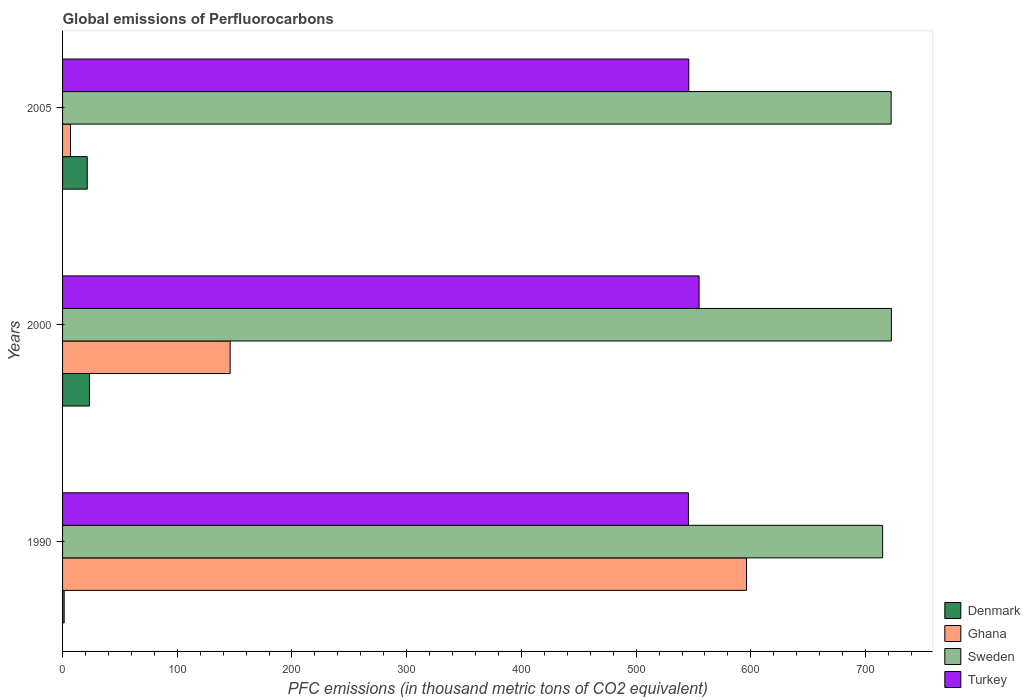Are the number of bars per tick equal to the number of legend labels?
Your answer should be very brief. Yes. How many bars are there on the 1st tick from the top?
Make the answer very short. 4. What is the label of the 2nd group of bars from the top?
Provide a short and direct response. 2000. In how many cases, is the number of bars for a given year not equal to the number of legend labels?
Provide a short and direct response. 0. What is the global emissions of Perfluorocarbons in Denmark in 2005?
Provide a succinct answer. 21.5. Across all years, what is the maximum global emissions of Perfluorocarbons in Turkey?
Give a very brief answer. 554.9. Across all years, what is the minimum global emissions of Perfluorocarbons in Denmark?
Provide a short and direct response. 1.4. In which year was the global emissions of Perfluorocarbons in Turkey maximum?
Ensure brevity in your answer.  2000. What is the total global emissions of Perfluorocarbons in Turkey in the graph?
Provide a short and direct response. 1646.4. What is the difference between the global emissions of Perfluorocarbons in Turkey in 1990 and the global emissions of Perfluorocarbons in Denmark in 2005?
Provide a succinct answer. 524.1. What is the average global emissions of Perfluorocarbons in Sweden per year?
Give a very brief answer. 719.9. In the year 2005, what is the difference between the global emissions of Perfluorocarbons in Ghana and global emissions of Perfluorocarbons in Turkey?
Keep it short and to the point. -539. What is the ratio of the global emissions of Perfluorocarbons in Sweden in 1990 to that in 2000?
Provide a short and direct response. 0.99. What is the difference between the highest and the second highest global emissions of Perfluorocarbons in Denmark?
Make the answer very short. 1.9. What is the difference between the highest and the lowest global emissions of Perfluorocarbons in Turkey?
Offer a very short reply. 9.3. In how many years, is the global emissions of Perfluorocarbons in Sweden greater than the average global emissions of Perfluorocarbons in Sweden taken over all years?
Offer a very short reply. 2. What does the 2nd bar from the top in 1990 represents?
Ensure brevity in your answer.  Sweden. What does the 2nd bar from the bottom in 2005 represents?
Your response must be concise. Ghana. How many bars are there?
Give a very brief answer. 12. Are all the bars in the graph horizontal?
Your response must be concise. Yes. What is the difference between two consecutive major ticks on the X-axis?
Your answer should be very brief. 100. Does the graph contain any zero values?
Your answer should be very brief. No. How many legend labels are there?
Keep it short and to the point. 4. What is the title of the graph?
Offer a terse response. Global emissions of Perfluorocarbons. Does "Andorra" appear as one of the legend labels in the graph?
Your answer should be very brief. No. What is the label or title of the X-axis?
Provide a short and direct response. PFC emissions (in thousand metric tons of CO2 equivalent). What is the PFC emissions (in thousand metric tons of CO2 equivalent) of Ghana in 1990?
Your answer should be very brief. 596.2. What is the PFC emissions (in thousand metric tons of CO2 equivalent) in Sweden in 1990?
Ensure brevity in your answer.  714.9. What is the PFC emissions (in thousand metric tons of CO2 equivalent) of Turkey in 1990?
Ensure brevity in your answer.  545.6. What is the PFC emissions (in thousand metric tons of CO2 equivalent) in Denmark in 2000?
Provide a short and direct response. 23.4. What is the PFC emissions (in thousand metric tons of CO2 equivalent) in Ghana in 2000?
Provide a succinct answer. 146.1. What is the PFC emissions (in thousand metric tons of CO2 equivalent) of Sweden in 2000?
Make the answer very short. 722.5. What is the PFC emissions (in thousand metric tons of CO2 equivalent) in Turkey in 2000?
Your answer should be very brief. 554.9. What is the PFC emissions (in thousand metric tons of CO2 equivalent) of Denmark in 2005?
Provide a short and direct response. 21.5. What is the PFC emissions (in thousand metric tons of CO2 equivalent) in Sweden in 2005?
Keep it short and to the point. 722.3. What is the PFC emissions (in thousand metric tons of CO2 equivalent) of Turkey in 2005?
Provide a short and direct response. 545.9. Across all years, what is the maximum PFC emissions (in thousand metric tons of CO2 equivalent) in Denmark?
Keep it short and to the point. 23.4. Across all years, what is the maximum PFC emissions (in thousand metric tons of CO2 equivalent) of Ghana?
Your answer should be very brief. 596.2. Across all years, what is the maximum PFC emissions (in thousand metric tons of CO2 equivalent) of Sweden?
Ensure brevity in your answer.  722.5. Across all years, what is the maximum PFC emissions (in thousand metric tons of CO2 equivalent) in Turkey?
Provide a short and direct response. 554.9. Across all years, what is the minimum PFC emissions (in thousand metric tons of CO2 equivalent) in Sweden?
Give a very brief answer. 714.9. Across all years, what is the minimum PFC emissions (in thousand metric tons of CO2 equivalent) in Turkey?
Offer a terse response. 545.6. What is the total PFC emissions (in thousand metric tons of CO2 equivalent) of Denmark in the graph?
Make the answer very short. 46.3. What is the total PFC emissions (in thousand metric tons of CO2 equivalent) in Ghana in the graph?
Your response must be concise. 749.2. What is the total PFC emissions (in thousand metric tons of CO2 equivalent) of Sweden in the graph?
Ensure brevity in your answer.  2159.7. What is the total PFC emissions (in thousand metric tons of CO2 equivalent) in Turkey in the graph?
Make the answer very short. 1646.4. What is the difference between the PFC emissions (in thousand metric tons of CO2 equivalent) in Ghana in 1990 and that in 2000?
Provide a succinct answer. 450.1. What is the difference between the PFC emissions (in thousand metric tons of CO2 equivalent) of Sweden in 1990 and that in 2000?
Your response must be concise. -7.6. What is the difference between the PFC emissions (in thousand metric tons of CO2 equivalent) in Turkey in 1990 and that in 2000?
Your answer should be very brief. -9.3. What is the difference between the PFC emissions (in thousand metric tons of CO2 equivalent) of Denmark in 1990 and that in 2005?
Offer a very short reply. -20.1. What is the difference between the PFC emissions (in thousand metric tons of CO2 equivalent) in Ghana in 1990 and that in 2005?
Keep it short and to the point. 589.3. What is the difference between the PFC emissions (in thousand metric tons of CO2 equivalent) of Sweden in 1990 and that in 2005?
Keep it short and to the point. -7.4. What is the difference between the PFC emissions (in thousand metric tons of CO2 equivalent) of Turkey in 1990 and that in 2005?
Provide a succinct answer. -0.3. What is the difference between the PFC emissions (in thousand metric tons of CO2 equivalent) of Denmark in 2000 and that in 2005?
Make the answer very short. 1.9. What is the difference between the PFC emissions (in thousand metric tons of CO2 equivalent) of Ghana in 2000 and that in 2005?
Provide a succinct answer. 139.2. What is the difference between the PFC emissions (in thousand metric tons of CO2 equivalent) of Denmark in 1990 and the PFC emissions (in thousand metric tons of CO2 equivalent) of Ghana in 2000?
Give a very brief answer. -144.7. What is the difference between the PFC emissions (in thousand metric tons of CO2 equivalent) in Denmark in 1990 and the PFC emissions (in thousand metric tons of CO2 equivalent) in Sweden in 2000?
Your answer should be very brief. -721.1. What is the difference between the PFC emissions (in thousand metric tons of CO2 equivalent) of Denmark in 1990 and the PFC emissions (in thousand metric tons of CO2 equivalent) of Turkey in 2000?
Offer a terse response. -553.5. What is the difference between the PFC emissions (in thousand metric tons of CO2 equivalent) of Ghana in 1990 and the PFC emissions (in thousand metric tons of CO2 equivalent) of Sweden in 2000?
Your answer should be very brief. -126.3. What is the difference between the PFC emissions (in thousand metric tons of CO2 equivalent) of Ghana in 1990 and the PFC emissions (in thousand metric tons of CO2 equivalent) of Turkey in 2000?
Provide a short and direct response. 41.3. What is the difference between the PFC emissions (in thousand metric tons of CO2 equivalent) of Sweden in 1990 and the PFC emissions (in thousand metric tons of CO2 equivalent) of Turkey in 2000?
Provide a short and direct response. 160. What is the difference between the PFC emissions (in thousand metric tons of CO2 equivalent) of Denmark in 1990 and the PFC emissions (in thousand metric tons of CO2 equivalent) of Sweden in 2005?
Your answer should be very brief. -720.9. What is the difference between the PFC emissions (in thousand metric tons of CO2 equivalent) of Denmark in 1990 and the PFC emissions (in thousand metric tons of CO2 equivalent) of Turkey in 2005?
Ensure brevity in your answer.  -544.5. What is the difference between the PFC emissions (in thousand metric tons of CO2 equivalent) in Ghana in 1990 and the PFC emissions (in thousand metric tons of CO2 equivalent) in Sweden in 2005?
Provide a succinct answer. -126.1. What is the difference between the PFC emissions (in thousand metric tons of CO2 equivalent) of Ghana in 1990 and the PFC emissions (in thousand metric tons of CO2 equivalent) of Turkey in 2005?
Ensure brevity in your answer.  50.3. What is the difference between the PFC emissions (in thousand metric tons of CO2 equivalent) in Sweden in 1990 and the PFC emissions (in thousand metric tons of CO2 equivalent) in Turkey in 2005?
Give a very brief answer. 169. What is the difference between the PFC emissions (in thousand metric tons of CO2 equivalent) in Denmark in 2000 and the PFC emissions (in thousand metric tons of CO2 equivalent) in Sweden in 2005?
Your response must be concise. -698.9. What is the difference between the PFC emissions (in thousand metric tons of CO2 equivalent) of Denmark in 2000 and the PFC emissions (in thousand metric tons of CO2 equivalent) of Turkey in 2005?
Offer a very short reply. -522.5. What is the difference between the PFC emissions (in thousand metric tons of CO2 equivalent) in Ghana in 2000 and the PFC emissions (in thousand metric tons of CO2 equivalent) in Sweden in 2005?
Provide a short and direct response. -576.2. What is the difference between the PFC emissions (in thousand metric tons of CO2 equivalent) of Ghana in 2000 and the PFC emissions (in thousand metric tons of CO2 equivalent) of Turkey in 2005?
Make the answer very short. -399.8. What is the difference between the PFC emissions (in thousand metric tons of CO2 equivalent) in Sweden in 2000 and the PFC emissions (in thousand metric tons of CO2 equivalent) in Turkey in 2005?
Keep it short and to the point. 176.6. What is the average PFC emissions (in thousand metric tons of CO2 equivalent) of Denmark per year?
Give a very brief answer. 15.43. What is the average PFC emissions (in thousand metric tons of CO2 equivalent) of Ghana per year?
Your answer should be very brief. 249.73. What is the average PFC emissions (in thousand metric tons of CO2 equivalent) of Sweden per year?
Make the answer very short. 719.9. What is the average PFC emissions (in thousand metric tons of CO2 equivalent) in Turkey per year?
Provide a short and direct response. 548.8. In the year 1990, what is the difference between the PFC emissions (in thousand metric tons of CO2 equivalent) in Denmark and PFC emissions (in thousand metric tons of CO2 equivalent) in Ghana?
Ensure brevity in your answer.  -594.8. In the year 1990, what is the difference between the PFC emissions (in thousand metric tons of CO2 equivalent) of Denmark and PFC emissions (in thousand metric tons of CO2 equivalent) of Sweden?
Keep it short and to the point. -713.5. In the year 1990, what is the difference between the PFC emissions (in thousand metric tons of CO2 equivalent) of Denmark and PFC emissions (in thousand metric tons of CO2 equivalent) of Turkey?
Offer a very short reply. -544.2. In the year 1990, what is the difference between the PFC emissions (in thousand metric tons of CO2 equivalent) of Ghana and PFC emissions (in thousand metric tons of CO2 equivalent) of Sweden?
Offer a very short reply. -118.7. In the year 1990, what is the difference between the PFC emissions (in thousand metric tons of CO2 equivalent) in Ghana and PFC emissions (in thousand metric tons of CO2 equivalent) in Turkey?
Your answer should be compact. 50.6. In the year 1990, what is the difference between the PFC emissions (in thousand metric tons of CO2 equivalent) of Sweden and PFC emissions (in thousand metric tons of CO2 equivalent) of Turkey?
Give a very brief answer. 169.3. In the year 2000, what is the difference between the PFC emissions (in thousand metric tons of CO2 equivalent) in Denmark and PFC emissions (in thousand metric tons of CO2 equivalent) in Ghana?
Your answer should be very brief. -122.7. In the year 2000, what is the difference between the PFC emissions (in thousand metric tons of CO2 equivalent) of Denmark and PFC emissions (in thousand metric tons of CO2 equivalent) of Sweden?
Provide a short and direct response. -699.1. In the year 2000, what is the difference between the PFC emissions (in thousand metric tons of CO2 equivalent) in Denmark and PFC emissions (in thousand metric tons of CO2 equivalent) in Turkey?
Your answer should be very brief. -531.5. In the year 2000, what is the difference between the PFC emissions (in thousand metric tons of CO2 equivalent) of Ghana and PFC emissions (in thousand metric tons of CO2 equivalent) of Sweden?
Your response must be concise. -576.4. In the year 2000, what is the difference between the PFC emissions (in thousand metric tons of CO2 equivalent) of Ghana and PFC emissions (in thousand metric tons of CO2 equivalent) of Turkey?
Offer a terse response. -408.8. In the year 2000, what is the difference between the PFC emissions (in thousand metric tons of CO2 equivalent) of Sweden and PFC emissions (in thousand metric tons of CO2 equivalent) of Turkey?
Offer a terse response. 167.6. In the year 2005, what is the difference between the PFC emissions (in thousand metric tons of CO2 equivalent) of Denmark and PFC emissions (in thousand metric tons of CO2 equivalent) of Ghana?
Your answer should be very brief. 14.6. In the year 2005, what is the difference between the PFC emissions (in thousand metric tons of CO2 equivalent) of Denmark and PFC emissions (in thousand metric tons of CO2 equivalent) of Sweden?
Your response must be concise. -700.8. In the year 2005, what is the difference between the PFC emissions (in thousand metric tons of CO2 equivalent) in Denmark and PFC emissions (in thousand metric tons of CO2 equivalent) in Turkey?
Give a very brief answer. -524.4. In the year 2005, what is the difference between the PFC emissions (in thousand metric tons of CO2 equivalent) in Ghana and PFC emissions (in thousand metric tons of CO2 equivalent) in Sweden?
Ensure brevity in your answer.  -715.4. In the year 2005, what is the difference between the PFC emissions (in thousand metric tons of CO2 equivalent) in Ghana and PFC emissions (in thousand metric tons of CO2 equivalent) in Turkey?
Make the answer very short. -539. In the year 2005, what is the difference between the PFC emissions (in thousand metric tons of CO2 equivalent) in Sweden and PFC emissions (in thousand metric tons of CO2 equivalent) in Turkey?
Keep it short and to the point. 176.4. What is the ratio of the PFC emissions (in thousand metric tons of CO2 equivalent) of Denmark in 1990 to that in 2000?
Offer a very short reply. 0.06. What is the ratio of the PFC emissions (in thousand metric tons of CO2 equivalent) of Ghana in 1990 to that in 2000?
Keep it short and to the point. 4.08. What is the ratio of the PFC emissions (in thousand metric tons of CO2 equivalent) of Turkey in 1990 to that in 2000?
Offer a very short reply. 0.98. What is the ratio of the PFC emissions (in thousand metric tons of CO2 equivalent) in Denmark in 1990 to that in 2005?
Your response must be concise. 0.07. What is the ratio of the PFC emissions (in thousand metric tons of CO2 equivalent) in Ghana in 1990 to that in 2005?
Give a very brief answer. 86.41. What is the ratio of the PFC emissions (in thousand metric tons of CO2 equivalent) of Sweden in 1990 to that in 2005?
Provide a succinct answer. 0.99. What is the ratio of the PFC emissions (in thousand metric tons of CO2 equivalent) of Denmark in 2000 to that in 2005?
Your response must be concise. 1.09. What is the ratio of the PFC emissions (in thousand metric tons of CO2 equivalent) in Ghana in 2000 to that in 2005?
Offer a terse response. 21.17. What is the ratio of the PFC emissions (in thousand metric tons of CO2 equivalent) in Turkey in 2000 to that in 2005?
Your answer should be compact. 1.02. What is the difference between the highest and the second highest PFC emissions (in thousand metric tons of CO2 equivalent) in Ghana?
Your response must be concise. 450.1. What is the difference between the highest and the second highest PFC emissions (in thousand metric tons of CO2 equivalent) in Sweden?
Provide a succinct answer. 0.2. What is the difference between the highest and the second highest PFC emissions (in thousand metric tons of CO2 equivalent) of Turkey?
Your response must be concise. 9. What is the difference between the highest and the lowest PFC emissions (in thousand metric tons of CO2 equivalent) in Ghana?
Ensure brevity in your answer.  589.3. 